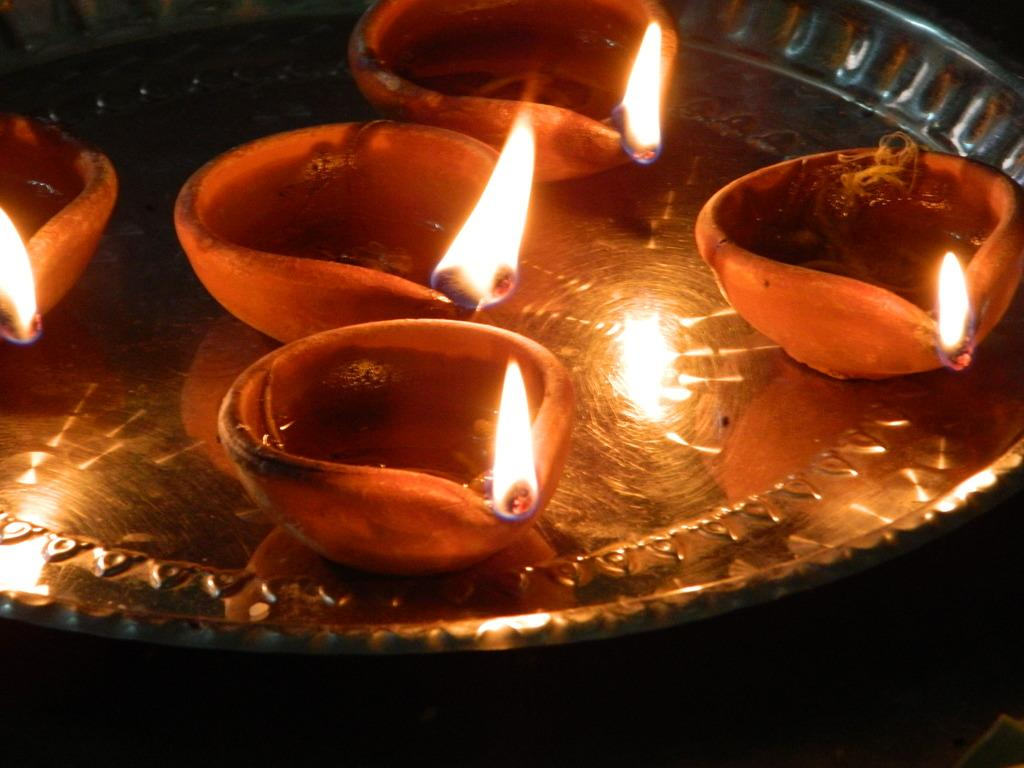What is depicted on the plate in the image? There are five days in a plate in the image. Can you describe the background of the image? The background of the image is dark. What type of dress is the sky wearing in the image? There is no sky or dress present in the image; it only features a plate with five days and a dark background. 